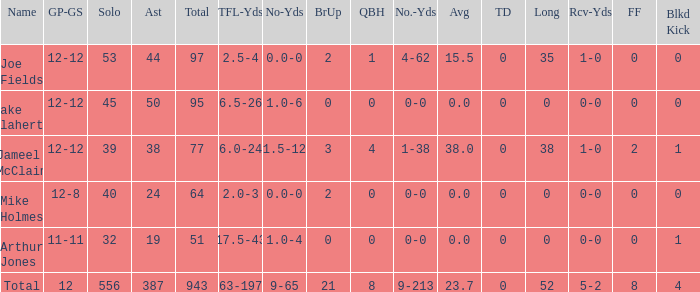5-4? 4-62. 